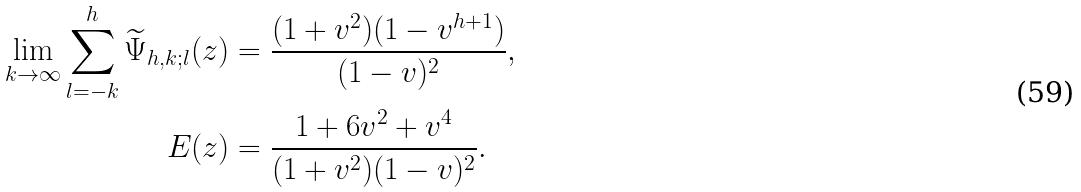<formula> <loc_0><loc_0><loc_500><loc_500>\lim _ { k \to \infty } \sum _ { l = - k } ^ { h } \widetilde { \Psi } _ { h , k ; l } ( z ) & = \frac { ( 1 + v ^ { 2 } ) ( 1 - v ^ { h + 1 } ) } { ( 1 - v ) ^ { 2 } } , \\ E ( z ) & = \frac { 1 + 6 v ^ { 2 } + v ^ { 4 } } { ( 1 + v ^ { 2 } ) ( 1 - v ) ^ { 2 } } .</formula> 